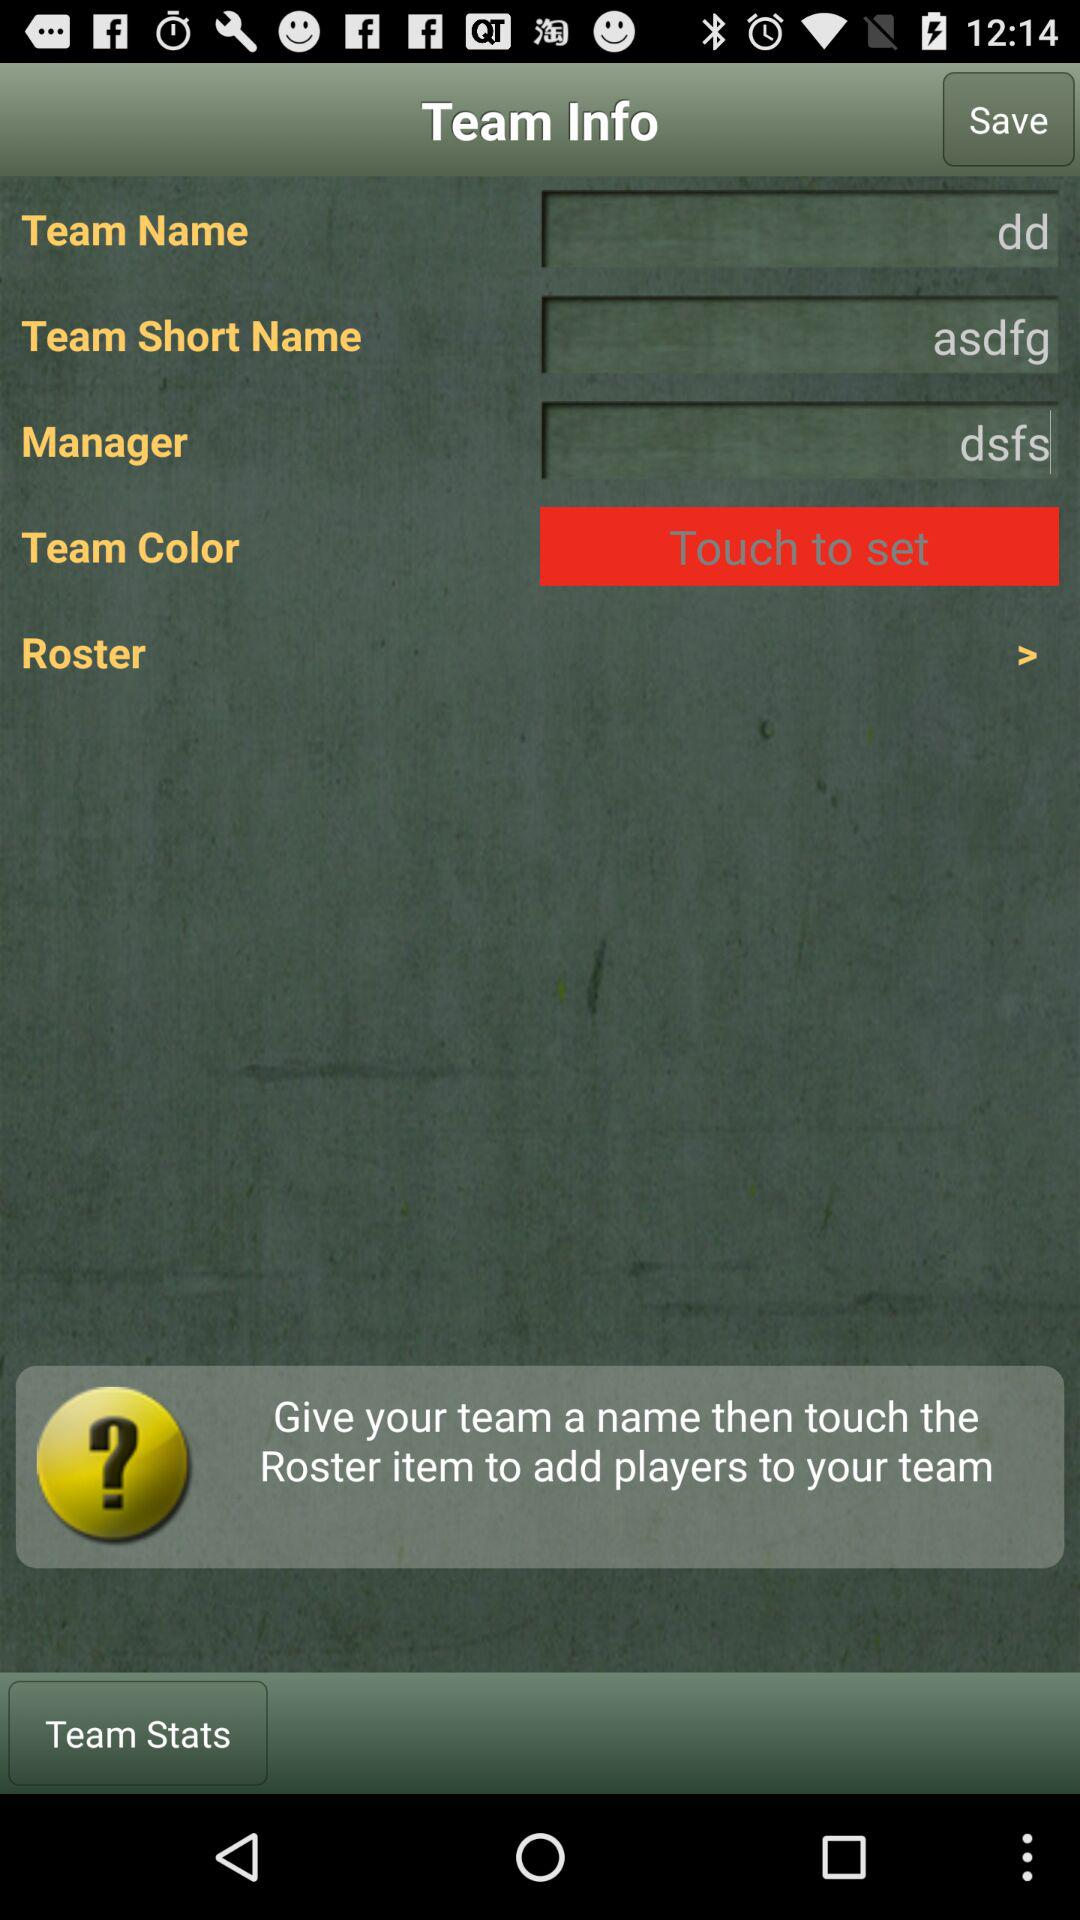What is "Team Short Name"? The "Team Short Name" is "asdfg". 